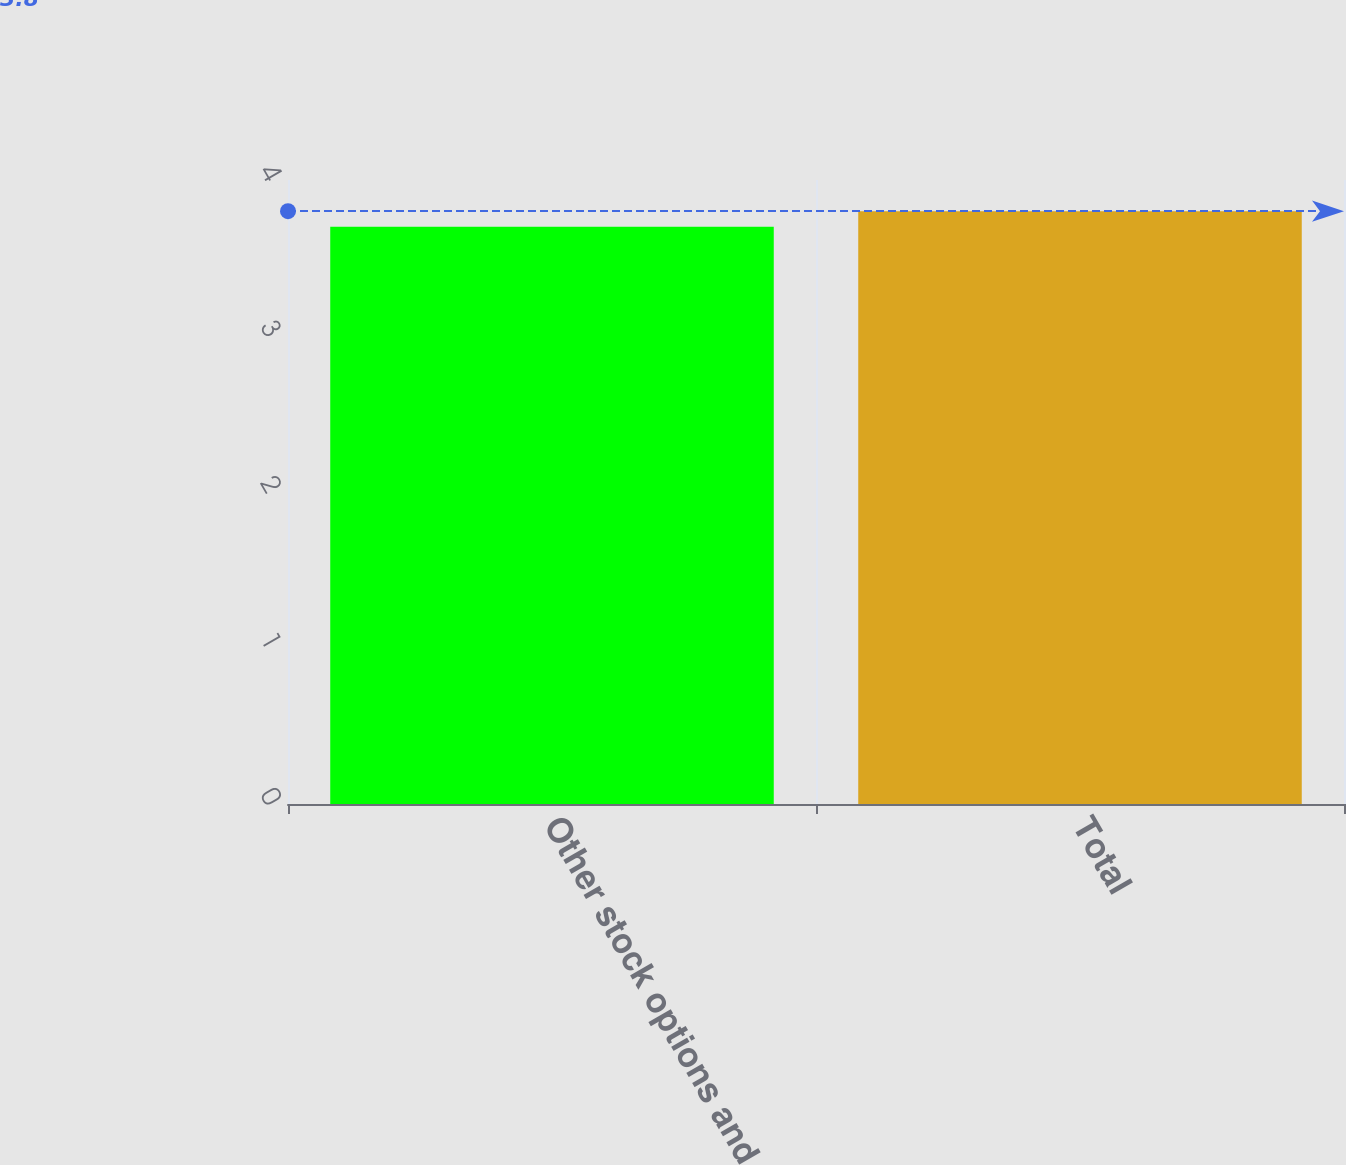<chart> <loc_0><loc_0><loc_500><loc_500><bar_chart><fcel>Other stock options and<fcel>Total<nl><fcel>3.7<fcel>3.8<nl></chart> 